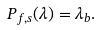<formula> <loc_0><loc_0><loc_500><loc_500>P _ { f , s } ( \lambda ) = \lambda _ { b } .</formula> 